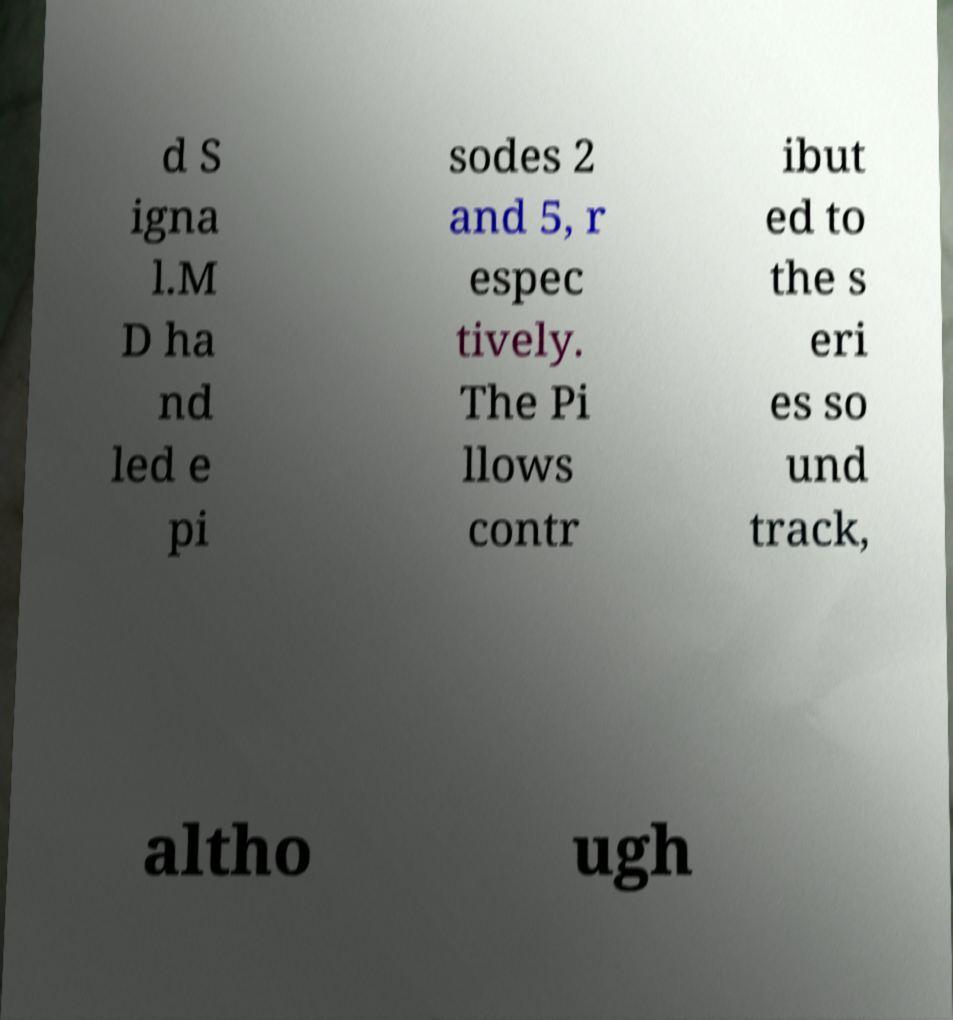Could you extract and type out the text from this image? d S igna l.M D ha nd led e pi sodes 2 and 5, r espec tively. The Pi llows contr ibut ed to the s eri es so und track, altho ugh 